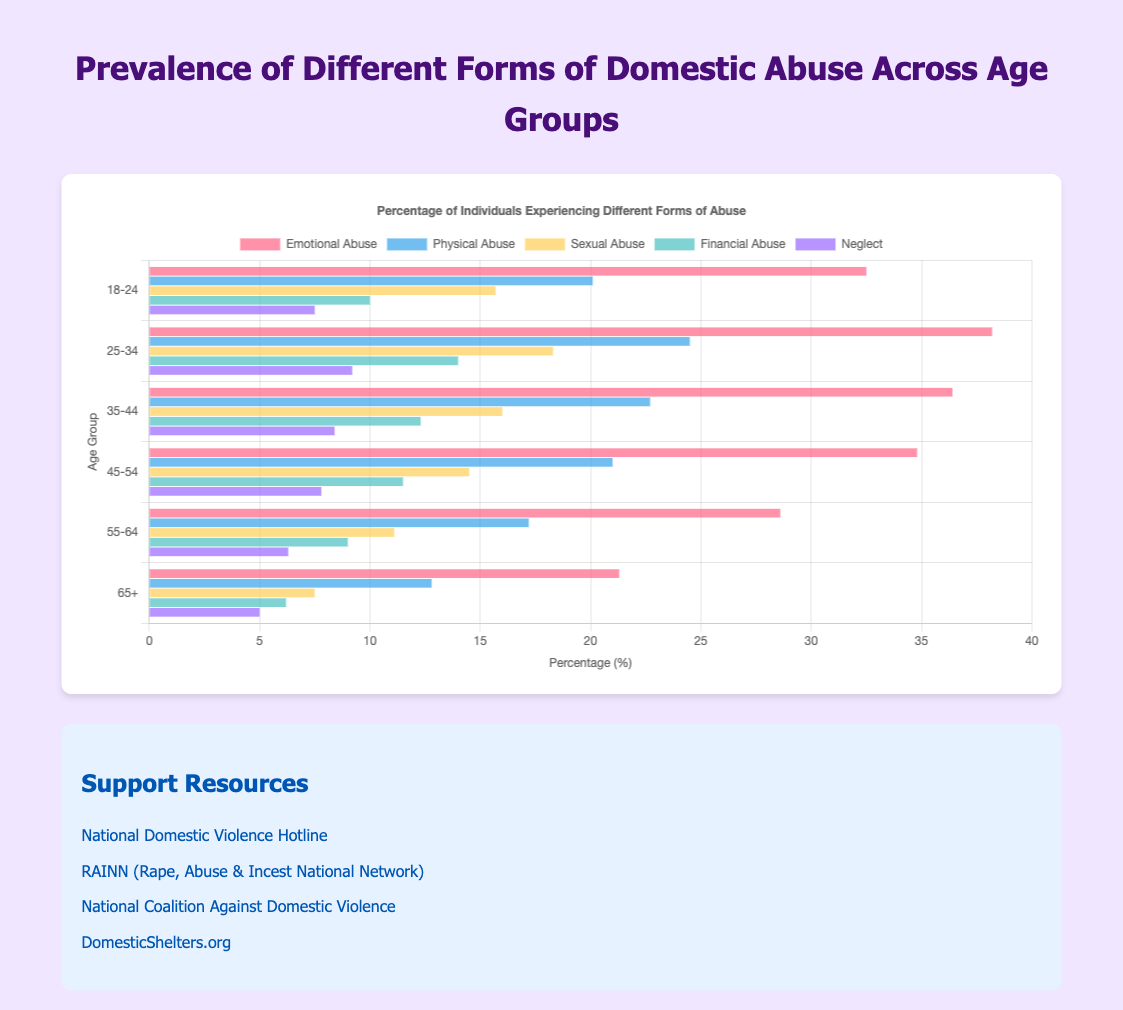What age group has the highest prevalence of emotional abuse? The age group with the highest bar for emotional abuse is 25-34.
Answer: 25-34 Which form of abuse is least prevalent in the 65+ age group? The smallest bar in the 65+ age group is for neglect, with a value of 5.0.
Answer: Neglect Compare the prevalence of sexual abuse between the 18-24 and 25-34 age groups. Which is higher and by how much? Sexual abuse is higher in the 25-34 age group (18.3) compared to the 18-24 age group (15.7). The difference is 18.3 - 15.7 = 2.6.
Answer: 25-34, by 2.6 What is the average prevalence of physical abuse across all age groups? Sum the percentages of physical abuse for all age groups (20.1 + 24.5 + 22.7 + 21.0 + 17.2 + 12.8) and divide by the number of groups (6). The calculation is (20.1 + 24.5 + 22.7 + 21.0 + 17.2 + 12.8) / 6 = 19.05.
Answer: 19.05 How does the prevalence of financial abuse in the 45-54 age group compare to that in the 55-64 age group? Financial abuse in the 45-54 age group is 11.5, and in the 55-64 age group is 9.0. The 45-54 group has a higher value by 11.5 - 9.0 = 2.5.
Answer: Higher by 2.5 What is the total prevalence of all forms of abuse in the 35-44 age group? Sum the prevalence values for all forms of abuse in the 35-44 age group: 36.4 + 22.7 + 16.0 + 12.3 + 8.4 = 95.8.
Answer: 95.8 Which form of abuse shows the most significant decrease in prevalence from the 25-34 to the 65+ age group? Calculate the decrease for each form of abuse between these age groups. Emotional: 38.2 - 21.3 = 16.9, Physical: 24.5 - 12.8 = 11.7, Sexual: 18.3 - 7.5 = 10.8, Financial: 14.0 - 6.2 = 7.8, Neglect: 9.2 - 5.0 = 4.2. Emotional abuse shows the most significant decrease of 16.9.
Answer: Emotional abuse What is the difference in the prevalence of neglect between the youngest (18-24) and oldest (65+) age groups? Subtract the prevalence of neglect in the 65+ age group (5.0) from that in the 18-24 age group (7.5), which gives 7.5 - 5.0 = 2.5.
Answer: 2.5 In which age group is financial abuse closest to the average value across all age groups? The average prevalence of financial abuse across all age groups is (10.0 + 14.0 + 12.3 + 11.5 + 9.0 + 6.2) / 6 = 10.5. Financial abuse in the 45-54 age group (11.5) is closest to the average of 10.5.
Answer: 45-54 